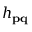<formula> <loc_0><loc_0><loc_500><loc_500>h _ { p q }</formula> 